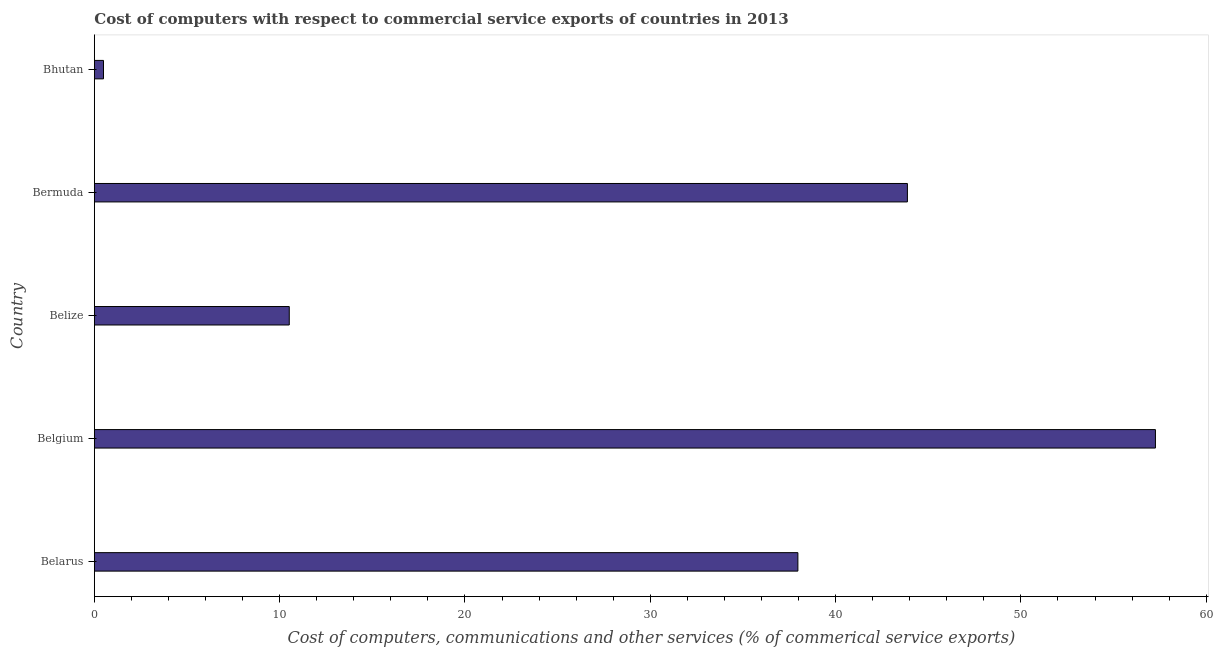What is the title of the graph?
Provide a short and direct response. Cost of computers with respect to commercial service exports of countries in 2013. What is the label or title of the X-axis?
Provide a short and direct response. Cost of computers, communications and other services (% of commerical service exports). What is the label or title of the Y-axis?
Your answer should be compact. Country. What is the  computer and other services in Bhutan?
Give a very brief answer. 0.49. Across all countries, what is the maximum  computer and other services?
Provide a short and direct response. 57.26. Across all countries, what is the minimum  computer and other services?
Offer a terse response. 0.49. In which country was the  computer and other services minimum?
Ensure brevity in your answer.  Bhutan. What is the sum of the cost of communications?
Make the answer very short. 150.11. What is the difference between the  computer and other services in Belarus and Belize?
Make the answer very short. 27.45. What is the average  computer and other services per country?
Provide a short and direct response. 30.02. What is the median  computer and other services?
Provide a short and direct response. 37.97. What is the ratio of the  computer and other services in Belize to that in Bermuda?
Offer a terse response. 0.24. Is the  computer and other services in Belize less than that in Bermuda?
Offer a terse response. Yes. Is the difference between the  computer and other services in Belarus and Bhutan greater than the difference between any two countries?
Offer a very short reply. No. What is the difference between the highest and the second highest  computer and other services?
Provide a succinct answer. 13.38. Is the sum of the  computer and other services in Belgium and Belize greater than the maximum  computer and other services across all countries?
Ensure brevity in your answer.  Yes. What is the difference between the highest and the lowest  computer and other services?
Provide a short and direct response. 56.76. How many bars are there?
Your response must be concise. 5. Are all the bars in the graph horizontal?
Ensure brevity in your answer.  Yes. What is the difference between two consecutive major ticks on the X-axis?
Provide a short and direct response. 10. Are the values on the major ticks of X-axis written in scientific E-notation?
Provide a succinct answer. No. What is the Cost of computers, communications and other services (% of commerical service exports) of Belarus?
Offer a terse response. 37.97. What is the Cost of computers, communications and other services (% of commerical service exports) in Belgium?
Keep it short and to the point. 57.26. What is the Cost of computers, communications and other services (% of commerical service exports) in Belize?
Offer a terse response. 10.52. What is the Cost of computers, communications and other services (% of commerical service exports) of Bermuda?
Provide a succinct answer. 43.88. What is the Cost of computers, communications and other services (% of commerical service exports) of Bhutan?
Your answer should be very brief. 0.49. What is the difference between the Cost of computers, communications and other services (% of commerical service exports) in Belarus and Belgium?
Ensure brevity in your answer.  -19.29. What is the difference between the Cost of computers, communications and other services (% of commerical service exports) in Belarus and Belize?
Offer a terse response. 27.45. What is the difference between the Cost of computers, communications and other services (% of commerical service exports) in Belarus and Bermuda?
Offer a very short reply. -5.91. What is the difference between the Cost of computers, communications and other services (% of commerical service exports) in Belarus and Bhutan?
Your response must be concise. 37.47. What is the difference between the Cost of computers, communications and other services (% of commerical service exports) in Belgium and Belize?
Offer a very short reply. 46.74. What is the difference between the Cost of computers, communications and other services (% of commerical service exports) in Belgium and Bermuda?
Keep it short and to the point. 13.38. What is the difference between the Cost of computers, communications and other services (% of commerical service exports) in Belgium and Bhutan?
Offer a very short reply. 56.76. What is the difference between the Cost of computers, communications and other services (% of commerical service exports) in Belize and Bermuda?
Provide a succinct answer. -33.36. What is the difference between the Cost of computers, communications and other services (% of commerical service exports) in Belize and Bhutan?
Your response must be concise. 10.02. What is the difference between the Cost of computers, communications and other services (% of commerical service exports) in Bermuda and Bhutan?
Offer a terse response. 43.38. What is the ratio of the Cost of computers, communications and other services (% of commerical service exports) in Belarus to that in Belgium?
Your answer should be very brief. 0.66. What is the ratio of the Cost of computers, communications and other services (% of commerical service exports) in Belarus to that in Belize?
Provide a succinct answer. 3.61. What is the ratio of the Cost of computers, communications and other services (% of commerical service exports) in Belarus to that in Bermuda?
Provide a short and direct response. 0.86. What is the ratio of the Cost of computers, communications and other services (% of commerical service exports) in Belarus to that in Bhutan?
Your answer should be very brief. 76.77. What is the ratio of the Cost of computers, communications and other services (% of commerical service exports) in Belgium to that in Belize?
Keep it short and to the point. 5.44. What is the ratio of the Cost of computers, communications and other services (% of commerical service exports) in Belgium to that in Bermuda?
Ensure brevity in your answer.  1.3. What is the ratio of the Cost of computers, communications and other services (% of commerical service exports) in Belgium to that in Bhutan?
Your answer should be very brief. 115.79. What is the ratio of the Cost of computers, communications and other services (% of commerical service exports) in Belize to that in Bermuda?
Keep it short and to the point. 0.24. What is the ratio of the Cost of computers, communications and other services (% of commerical service exports) in Belize to that in Bhutan?
Offer a very short reply. 21.27. What is the ratio of the Cost of computers, communications and other services (% of commerical service exports) in Bermuda to that in Bhutan?
Keep it short and to the point. 88.72. 